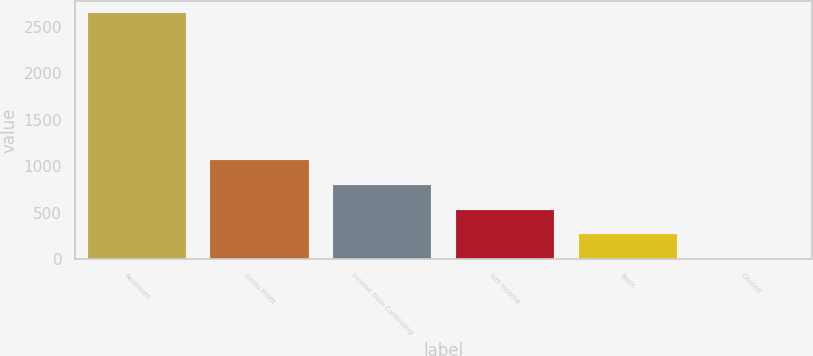<chart> <loc_0><loc_0><loc_500><loc_500><bar_chart><fcel>Revenues<fcel>Gross Profit<fcel>Income from Continuing<fcel>Net Income<fcel>Basic<fcel>Diluted<nl><fcel>2646.3<fcel>1066.9<fcel>794.36<fcel>529.8<fcel>265.24<fcel>0.68<nl></chart> 